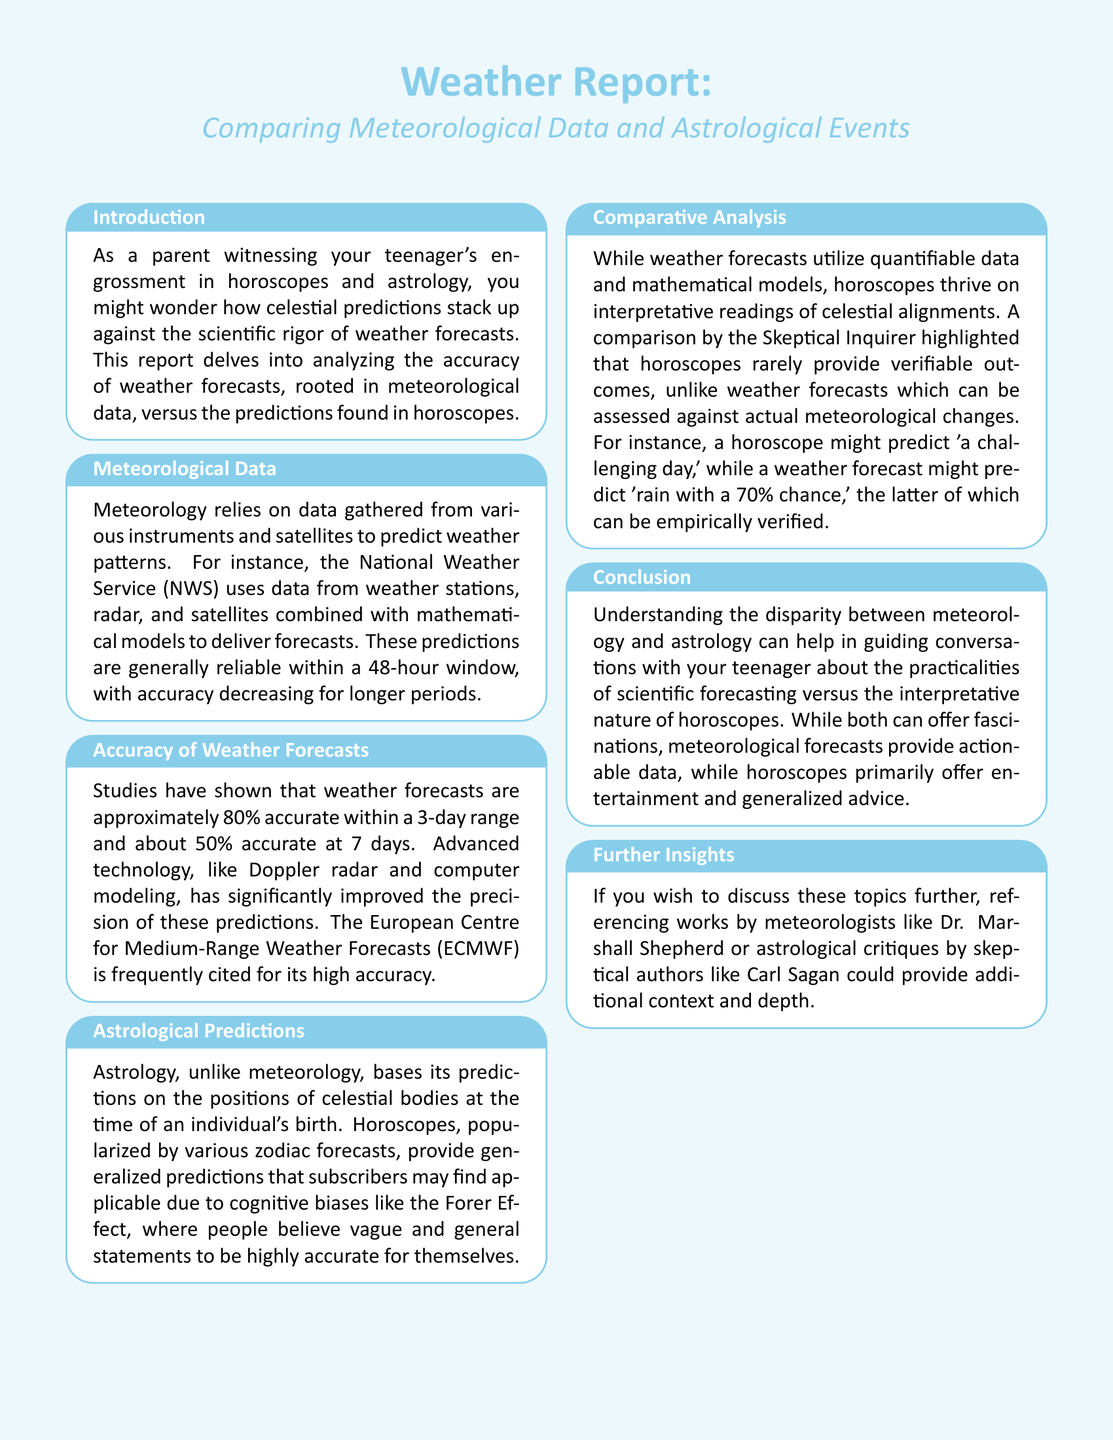What is the main topic of the report? The report compares the accuracy of weather forecasts with horoscope predictions.
Answer: Comparing Meteorological Data and Astrological Events What percentage of accuracy do weather forecasts have within a 3-day range? The document states that weather forecasts are approximately 80% accurate within a 3-day range.
Answer: 80% What effect explains why people find horoscopes applicable to themselves? The cognitive bias that causes people to find vague statements personally relevant is called the Forer Effect.
Answer: Forer Effect What is the primary basis for astrological predictions? Horoscopes are based on the positions of celestial bodies at an individual's birth.
Answer: Positions of celestial bodies How does the accuracy of weather forecasts change after seven days? The document mentions that accuracy drops to about 50% for forecasts beyond a 7-day period.
Answer: 50% What is a key difference between meteorological and astrological predictions? Weather forecasts rely on quantifiable data, while horoscopes are based on interpretative readings.
Answer: Quantifiable data vs. interpretative readings What is the title of a notable organization for weather forecasting mentioned in the document? The European Centre for Medium-Range Weather Forecasts (ECMWF) is highlighted for its accuracy.
Answer: European Centre for Medium-Range Weather Forecasts What type of insights does the conclusion encourage parents to have with their teenagers? The conclusion suggests guiding conversations about the difference between scientific forecasting and the interpretative nature of horoscopes.
Answer: Conversations about scientific forecasting What does the document suggest horoscopes primarily offer? Horoscopes mainly provide entertainment and generalized advice according to the document.
Answer: Entertainment and generalized advice 